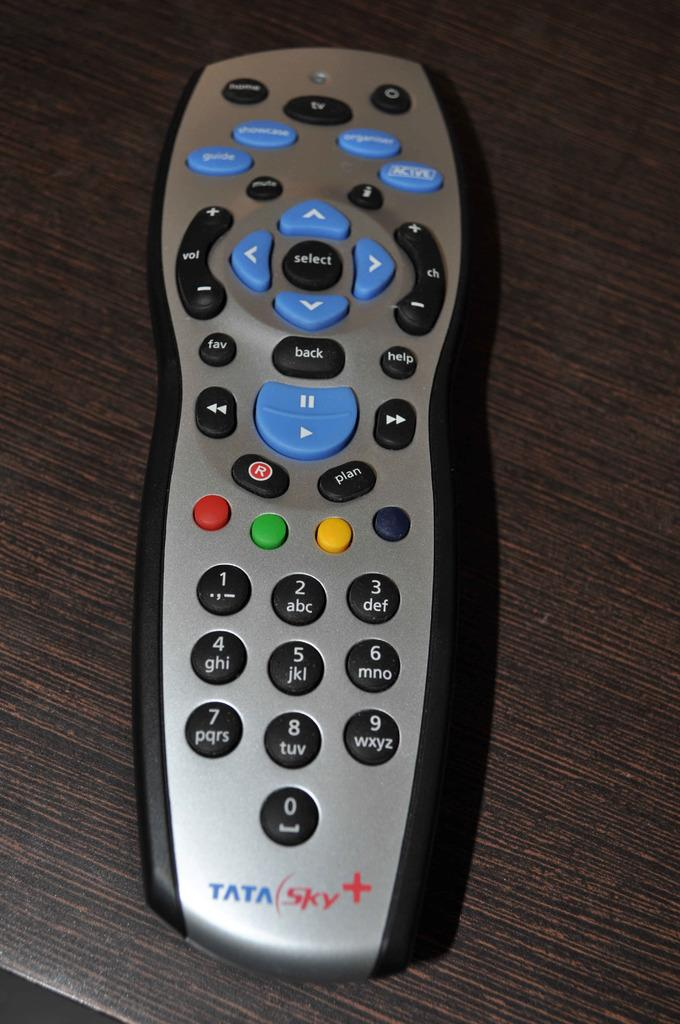<image>
Offer a succinct explanation of the picture presented. Silver remote controller by Tata Sky on a table. 